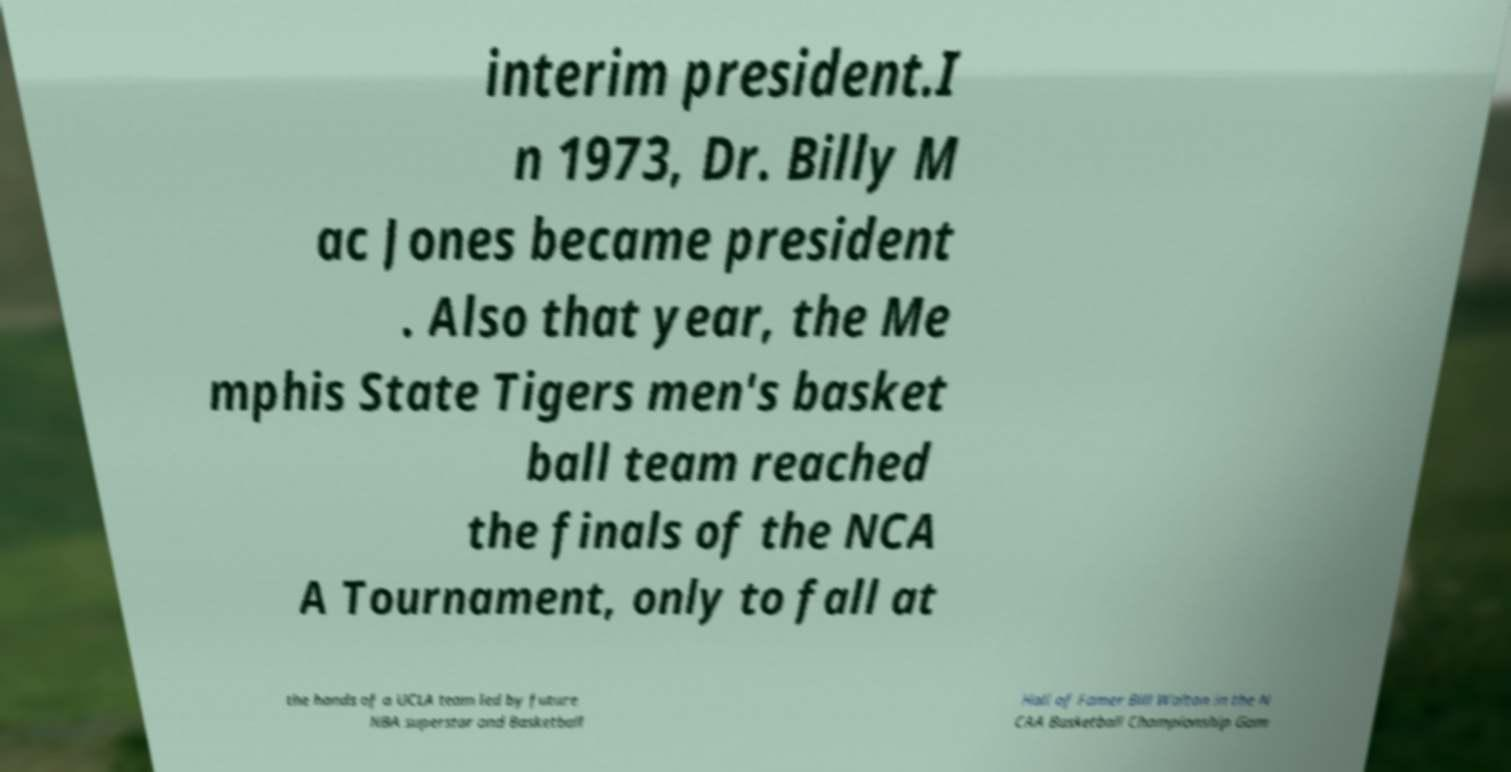Please identify and transcribe the text found in this image. interim president.I n 1973, Dr. Billy M ac Jones became president . Also that year, the Me mphis State Tigers men's basket ball team reached the finals of the NCA A Tournament, only to fall at the hands of a UCLA team led by future NBA superstar and Basketball Hall of Famer Bill Walton in the N CAA Basketball Championship Gam 